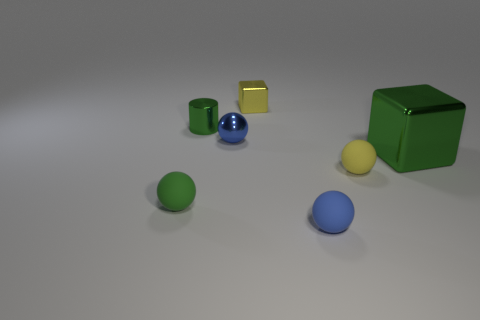Does the tiny metal object that is on the right side of the small blue metallic ball have the same color as the metal ball?
Give a very brief answer. No. Is the number of small cubes that are in front of the tiny yellow metal cube greater than the number of small yellow metallic objects?
Ensure brevity in your answer.  No. Are there any other things that are the same color as the metallic cylinder?
Your answer should be compact. Yes. What is the shape of the small blue thing on the right side of the tiny sphere that is behind the green shiny block?
Offer a very short reply. Sphere. Is the number of big green objects greater than the number of purple rubber cylinders?
Keep it short and to the point. Yes. How many small objects are on the right side of the green cylinder and in front of the big metal thing?
Your answer should be very brief. 2. How many small yellow things are in front of the tiny green cylinder that is behind the blue shiny thing?
Your answer should be compact. 1. How many objects are tiny rubber spheres that are in front of the green matte sphere or spheres that are on the right side of the small green matte thing?
Provide a succinct answer. 3. What is the material of the large object that is the same shape as the tiny yellow metallic thing?
Give a very brief answer. Metal. How many objects are either green things that are right of the small metal cylinder or brown metallic cylinders?
Provide a succinct answer. 1. 